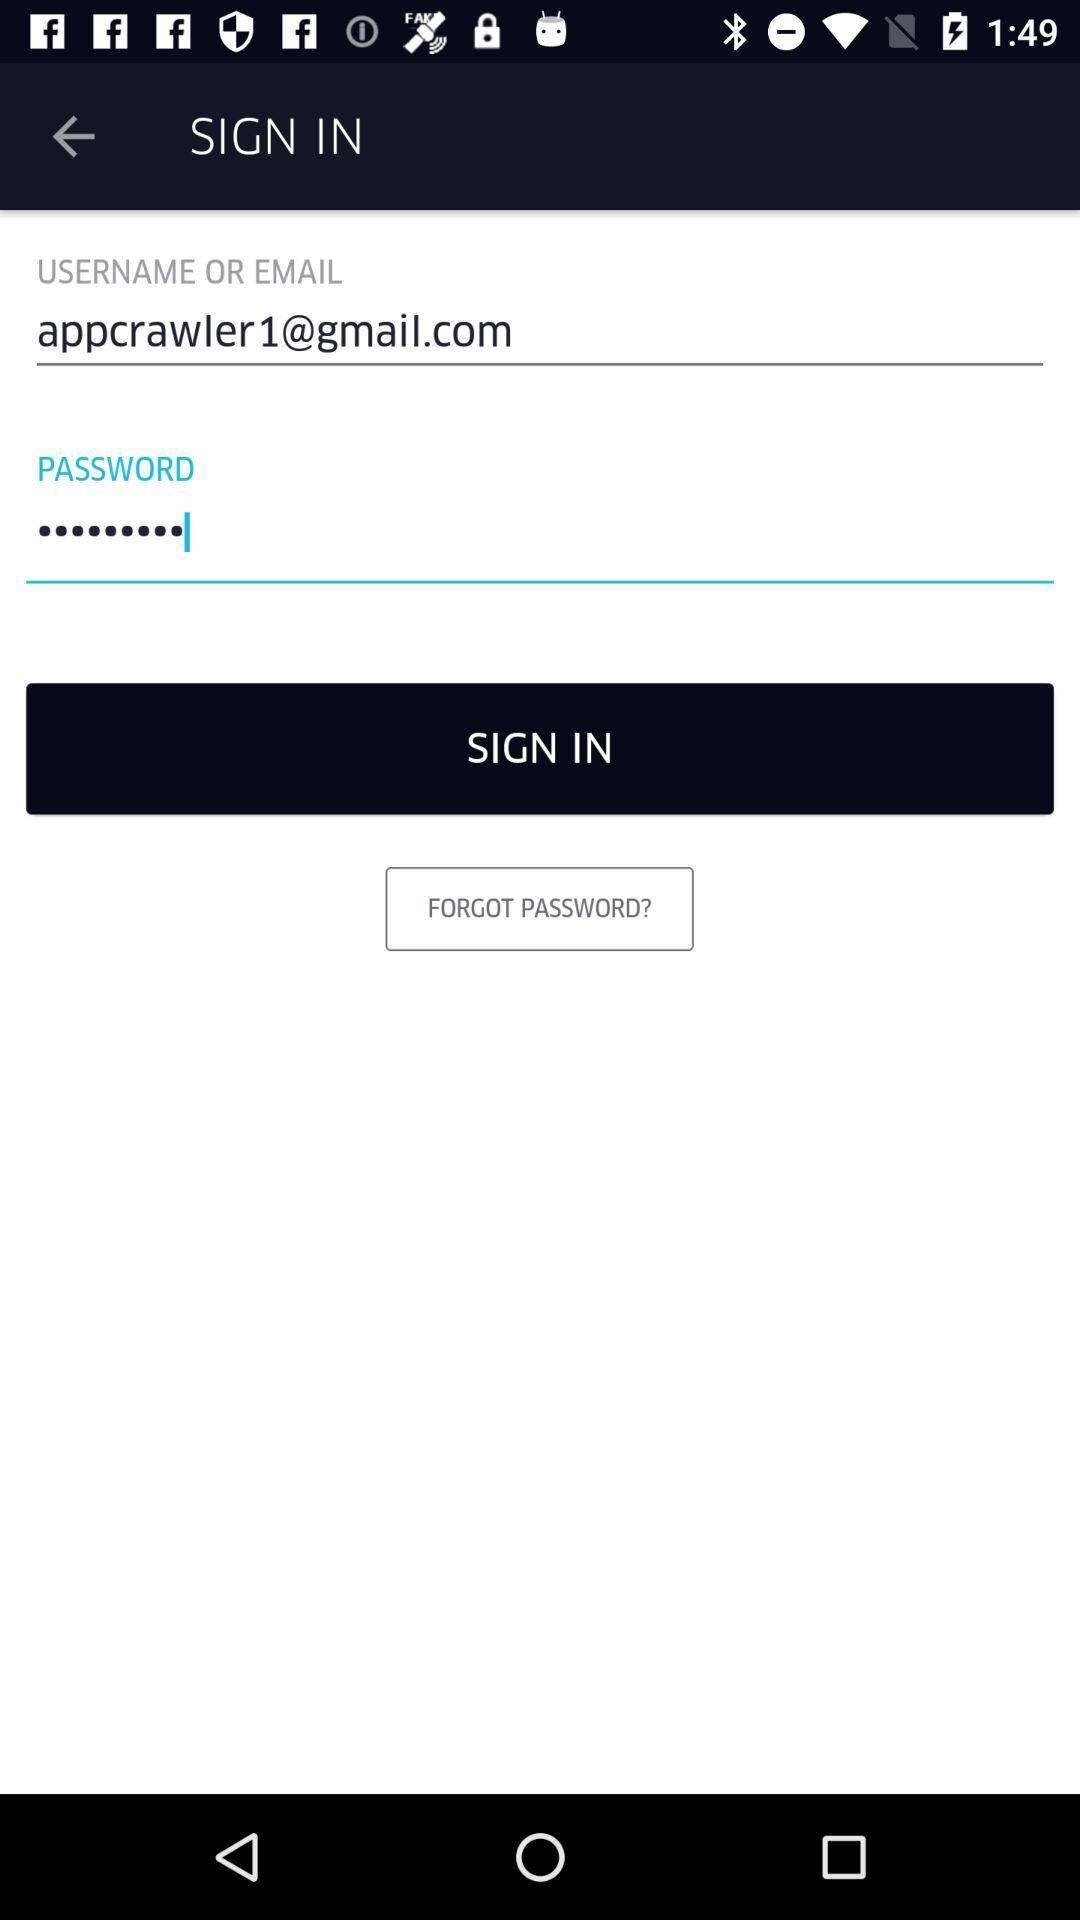What is the email address? The email address is appcrawler1@gmail.com. 